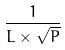Convert formula to latex. <formula><loc_0><loc_0><loc_500><loc_500>\frac { 1 } { L \times \sqrt { P } }</formula> 